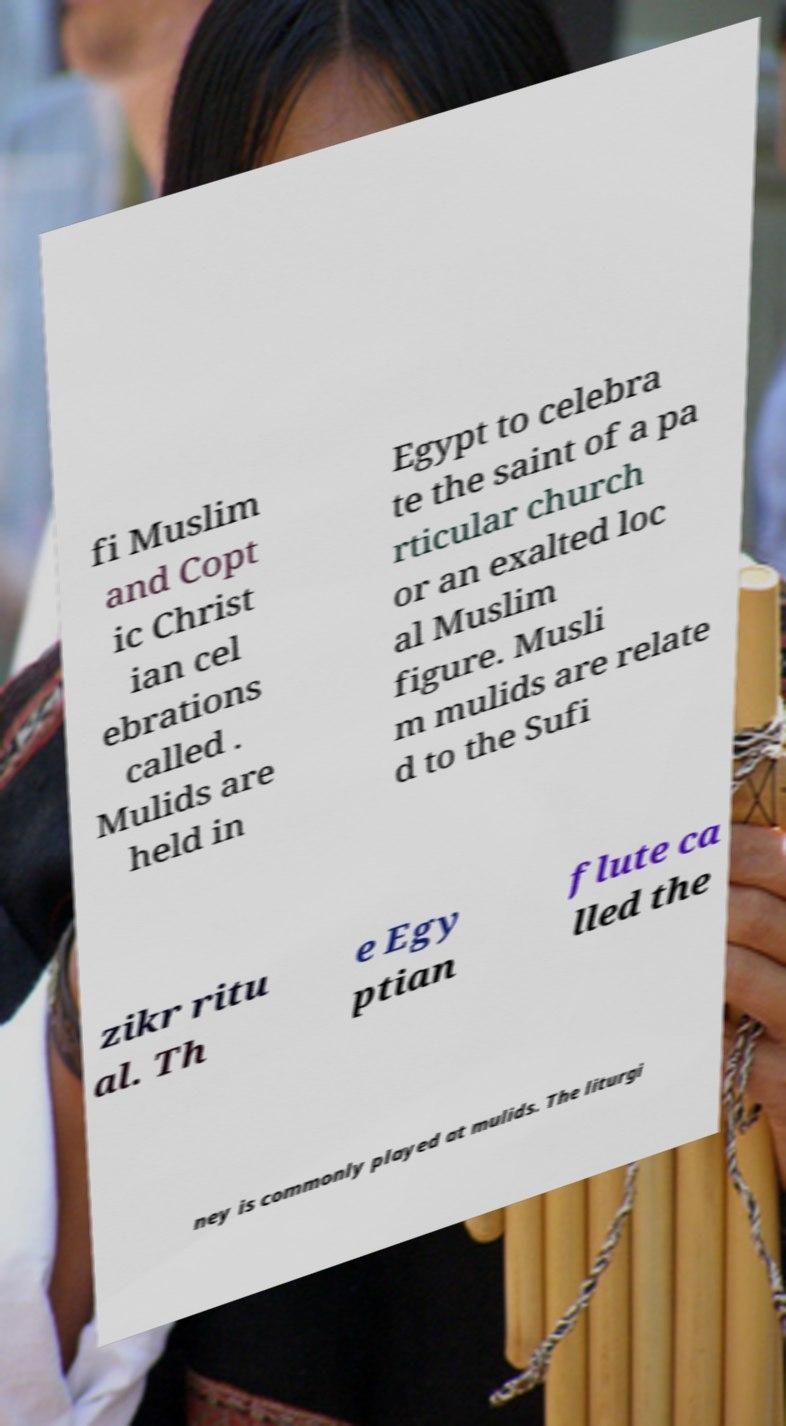Could you extract and type out the text from this image? fi Muslim and Copt ic Christ ian cel ebrations called . Mulids are held in Egypt to celebra te the saint of a pa rticular church or an exalted loc al Muslim figure. Musli m mulids are relate d to the Sufi zikr ritu al. Th e Egy ptian flute ca lled the ney is commonly played at mulids. The liturgi 